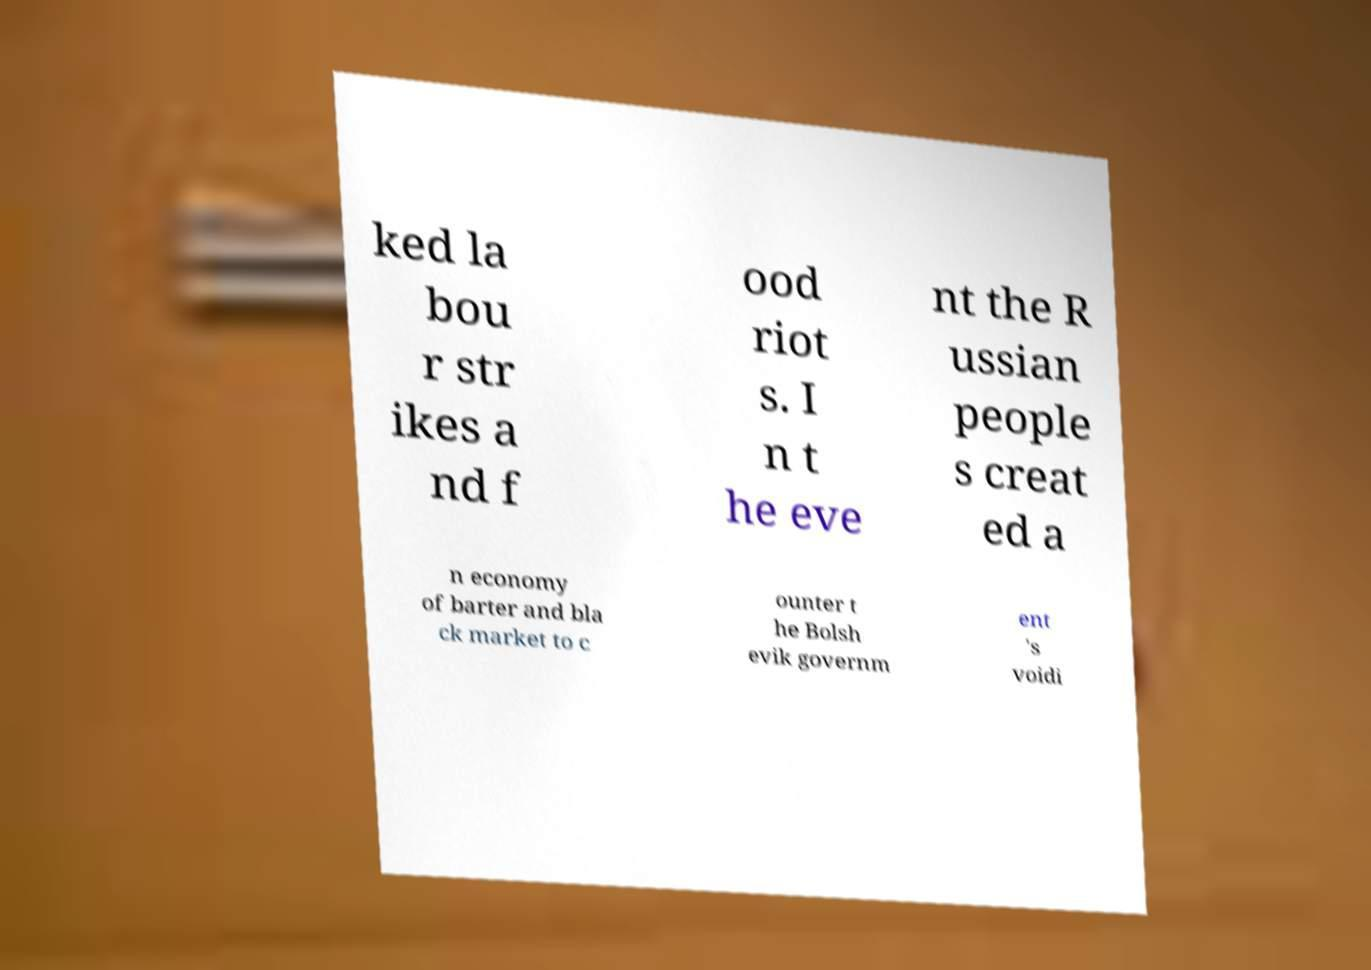Could you extract and type out the text from this image? ked la bou r str ikes a nd f ood riot s. I n t he eve nt the R ussian people s creat ed a n economy of barter and bla ck market to c ounter t he Bolsh evik governm ent 's voidi 